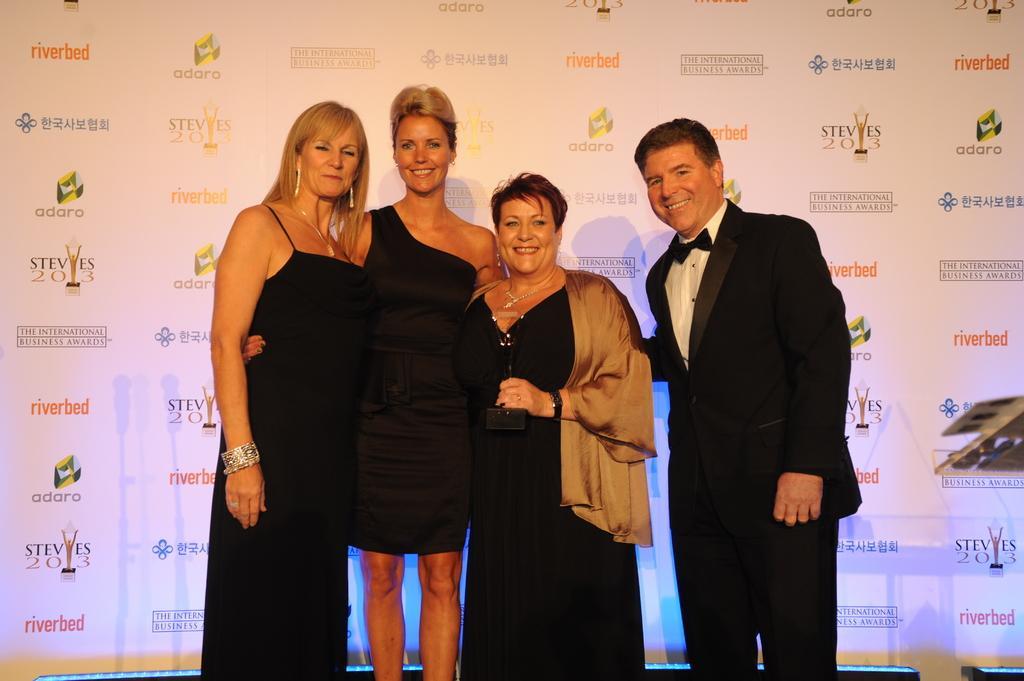In one or two sentences, can you explain what this image depicts? In this image there are a few people standing with a smile on their face, behind them there is a banner with some sponsor's name. 